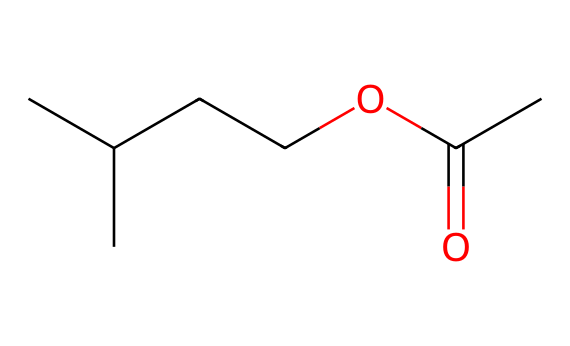What is the molecular formula of isopentyl acetate? To determine the molecular formula, count the number of each type of atom in the SMILES representation. It includes 7 carbon (C) atoms, 14 hydrogen (H) atoms, and 2 oxygen (O) atoms. Thus, the molecular formula is C7H14O2.
Answer: C7H14O2 How many carbon atoms are present in isopentyl acetate? By analyzing the SMILES representation, we can count the carbon atoms. There are 7 occurrences of 'C', which corresponds to 7 carbon atoms in total.
Answer: 7 What type of functional group is present in isopentyl acetate? The SMILES shows a carbonyl group (C=O) attached to an alkoxy group (R-O), which characterizes it as an ester. The presence of the -COOC- functional group indicates it belongs to the ester class.
Answer: ester What is the unique feature in the structure of isopentyl acetate that contributes to its fruity aroma? The ester functional group is responsible for fruity aroma in many compounds. In this case, the combination of the carbon chain and the ester linkage gives isopentyl acetate its characteristic banana flavor.
Answer: ester functional group How many double bonds are there in isopentyl acetate? In the SMILES structure, there is only one double bond present, which is found between the carbon and the oxygen in the carbonyl group (C=O). Therefore, there is 1 double bond.
Answer: 1 Which part of the molecule is responsible for its solubility in organic solvents? The long hydrocarbon chain (the carbon backbone) and the presence of the ester functional group (which can interact with other organic molecules) contribute to the solubility in organic solvents.
Answer: hydrocarbon chain and ester functional group 